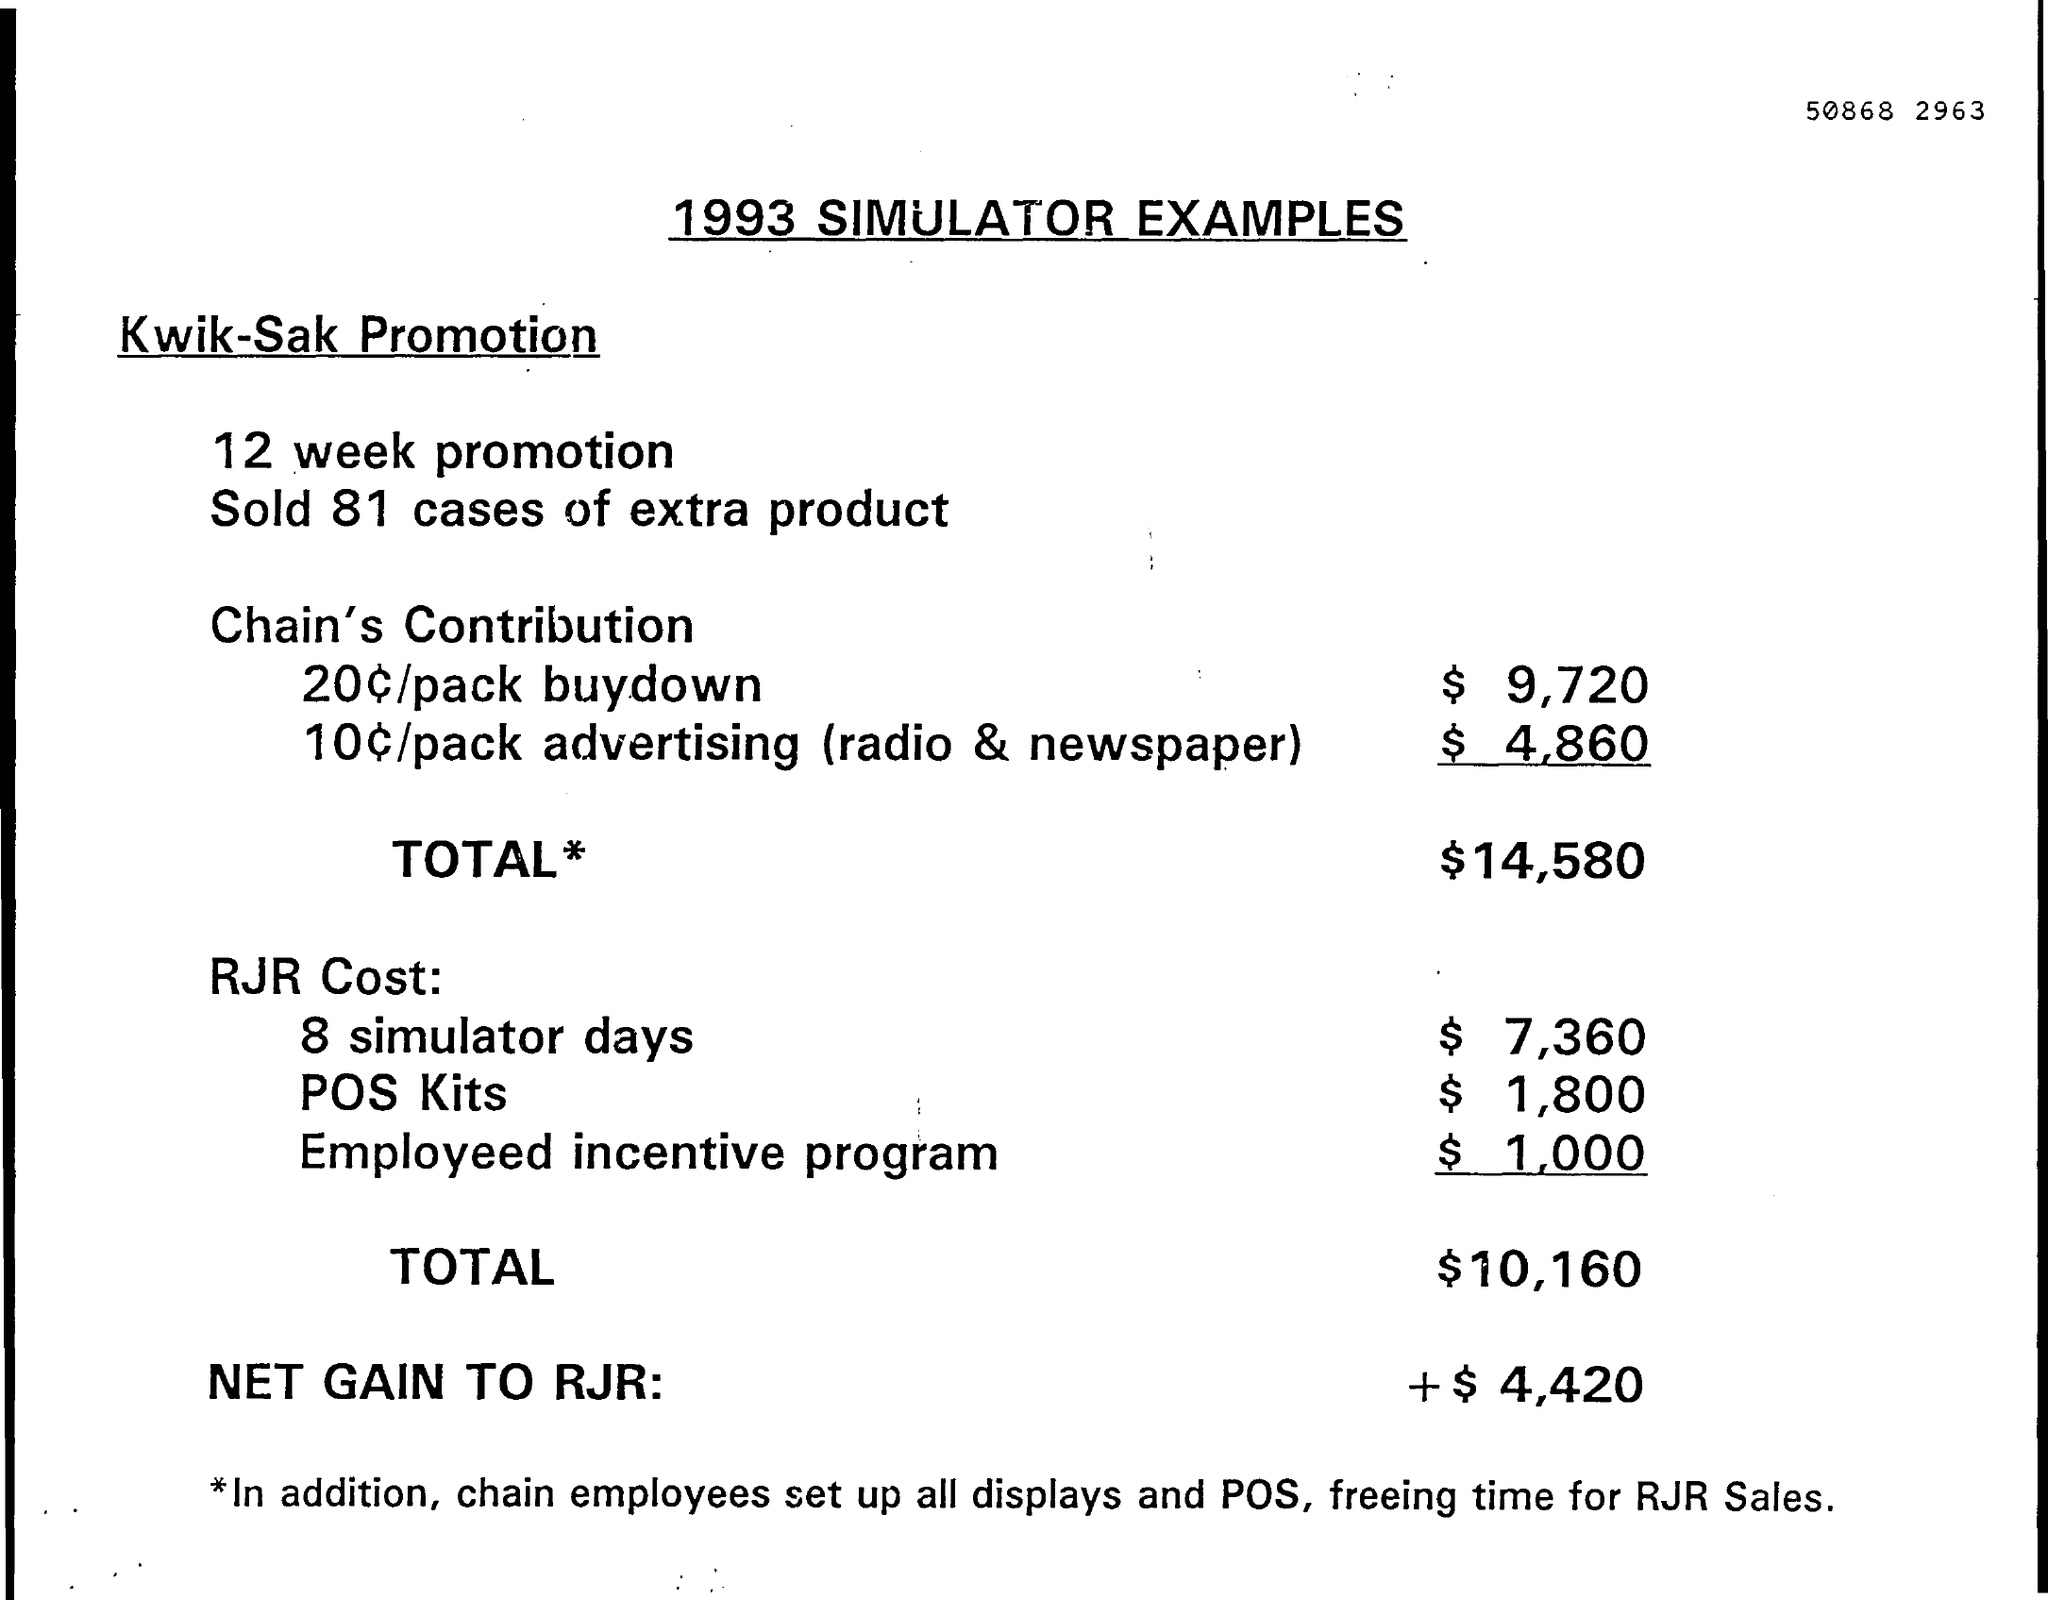Which year these simulator examples belongs to ?
Your answer should be compact. 1993. How many extra product cases where sold ?
Keep it short and to the point. 81. What is the total amount of china's contribution ?
Provide a short and direct response. $14,580. What is the net gain of the rjr ?
Your answer should be very brief. +$4,420. What is the total cost of rjr ?
Your answer should be compact. $10,160. 